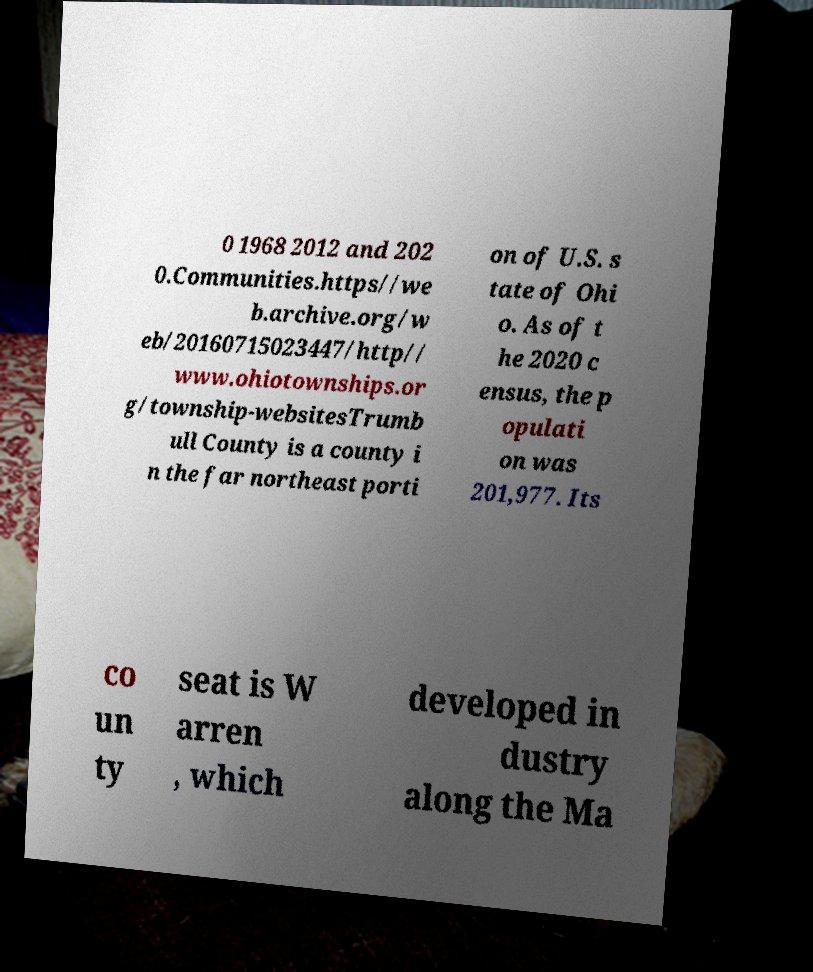For documentation purposes, I need the text within this image transcribed. Could you provide that? 0 1968 2012 and 202 0.Communities.https//we b.archive.org/w eb/20160715023447/http// www.ohiotownships.or g/township-websitesTrumb ull County is a county i n the far northeast porti on of U.S. s tate of Ohi o. As of t he 2020 c ensus, the p opulati on was 201,977. Its co un ty seat is W arren , which developed in dustry along the Ma 